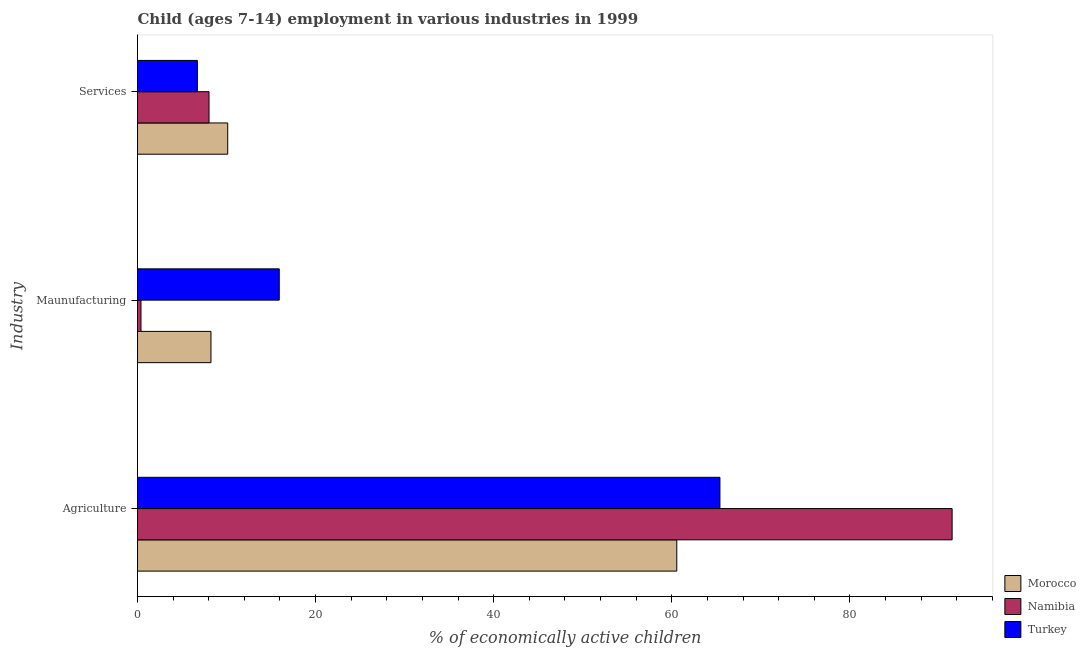How many different coloured bars are there?
Your answer should be compact. 3. How many bars are there on the 1st tick from the top?
Your response must be concise. 3. How many bars are there on the 1st tick from the bottom?
Your answer should be compact. 3. What is the label of the 1st group of bars from the top?
Your answer should be very brief. Services. What is the percentage of economically active children in manufacturing in Morocco?
Offer a very short reply. 8.25. Across all countries, what is the maximum percentage of economically active children in services?
Give a very brief answer. 10.13. Across all countries, what is the minimum percentage of economically active children in agriculture?
Provide a succinct answer. 60.56. In which country was the percentage of economically active children in manufacturing maximum?
Ensure brevity in your answer.  Turkey. What is the total percentage of economically active children in agriculture in the graph?
Ensure brevity in your answer.  217.45. What is the difference between the percentage of economically active children in services in Namibia and that in Turkey?
Your response must be concise. 1.31. What is the difference between the percentage of economically active children in services in Turkey and the percentage of economically active children in agriculture in Namibia?
Your answer should be compact. -84.76. What is the average percentage of economically active children in agriculture per country?
Your response must be concise. 72.48. What is the difference between the percentage of economically active children in manufacturing and percentage of economically active children in services in Namibia?
Your answer should be compact. -7.64. In how many countries, is the percentage of economically active children in services greater than 88 %?
Offer a terse response. 0. What is the ratio of the percentage of economically active children in agriculture in Turkey to that in Morocco?
Keep it short and to the point. 1.08. Is the percentage of economically active children in services in Turkey less than that in Namibia?
Provide a succinct answer. Yes. What is the difference between the highest and the second highest percentage of economically active children in agriculture?
Provide a short and direct response. 26.07. What is the difference between the highest and the lowest percentage of economically active children in agriculture?
Offer a very short reply. 30.92. In how many countries, is the percentage of economically active children in manufacturing greater than the average percentage of economically active children in manufacturing taken over all countries?
Ensure brevity in your answer.  2. What does the 3rd bar from the top in Agriculture represents?
Provide a short and direct response. Morocco. What does the 2nd bar from the bottom in Services represents?
Your answer should be very brief. Namibia. How many bars are there?
Your answer should be very brief. 9. Are the values on the major ticks of X-axis written in scientific E-notation?
Your response must be concise. No. Does the graph contain any zero values?
Your answer should be very brief. No. Does the graph contain grids?
Your response must be concise. No. How many legend labels are there?
Keep it short and to the point. 3. What is the title of the graph?
Your answer should be very brief. Child (ages 7-14) employment in various industries in 1999. What is the label or title of the X-axis?
Ensure brevity in your answer.  % of economically active children. What is the label or title of the Y-axis?
Offer a terse response. Industry. What is the % of economically active children of Morocco in Agriculture?
Give a very brief answer. 60.56. What is the % of economically active children of Namibia in Agriculture?
Offer a very short reply. 91.48. What is the % of economically active children in Turkey in Agriculture?
Give a very brief answer. 65.41. What is the % of economically active children of Morocco in Maunufacturing?
Make the answer very short. 8.25. What is the % of economically active children in Namibia in Maunufacturing?
Provide a short and direct response. 0.39. What is the % of economically active children in Turkey in Maunufacturing?
Your response must be concise. 15.92. What is the % of economically active children in Morocco in Services?
Your answer should be very brief. 10.13. What is the % of economically active children in Namibia in Services?
Your response must be concise. 8.03. What is the % of economically active children in Turkey in Services?
Make the answer very short. 6.72. Across all Industry, what is the maximum % of economically active children of Morocco?
Make the answer very short. 60.56. Across all Industry, what is the maximum % of economically active children of Namibia?
Your answer should be very brief. 91.48. Across all Industry, what is the maximum % of economically active children in Turkey?
Your answer should be compact. 65.41. Across all Industry, what is the minimum % of economically active children in Morocco?
Provide a succinct answer. 8.25. Across all Industry, what is the minimum % of economically active children in Namibia?
Provide a short and direct response. 0.39. Across all Industry, what is the minimum % of economically active children in Turkey?
Your answer should be compact. 6.72. What is the total % of economically active children of Morocco in the graph?
Offer a terse response. 78.94. What is the total % of economically active children in Namibia in the graph?
Provide a succinct answer. 99.9. What is the total % of economically active children in Turkey in the graph?
Ensure brevity in your answer.  88.05. What is the difference between the % of economically active children of Morocco in Agriculture and that in Maunufacturing?
Your answer should be compact. 52.31. What is the difference between the % of economically active children of Namibia in Agriculture and that in Maunufacturing?
Ensure brevity in your answer.  91.09. What is the difference between the % of economically active children of Turkey in Agriculture and that in Maunufacturing?
Your answer should be very brief. 49.49. What is the difference between the % of economically active children in Morocco in Agriculture and that in Services?
Your response must be concise. 50.43. What is the difference between the % of economically active children in Namibia in Agriculture and that in Services?
Provide a succinct answer. 83.45. What is the difference between the % of economically active children of Turkey in Agriculture and that in Services?
Make the answer very short. 58.68. What is the difference between the % of economically active children of Morocco in Maunufacturing and that in Services?
Provide a succinct answer. -1.88. What is the difference between the % of economically active children of Namibia in Maunufacturing and that in Services?
Your answer should be compact. -7.64. What is the difference between the % of economically active children in Turkey in Maunufacturing and that in Services?
Offer a very short reply. 9.2. What is the difference between the % of economically active children of Morocco in Agriculture and the % of economically active children of Namibia in Maunufacturing?
Keep it short and to the point. 60.17. What is the difference between the % of economically active children of Morocco in Agriculture and the % of economically active children of Turkey in Maunufacturing?
Offer a terse response. 44.64. What is the difference between the % of economically active children of Namibia in Agriculture and the % of economically active children of Turkey in Maunufacturing?
Offer a very short reply. 75.56. What is the difference between the % of economically active children in Morocco in Agriculture and the % of economically active children in Namibia in Services?
Your answer should be very brief. 52.53. What is the difference between the % of economically active children of Morocco in Agriculture and the % of economically active children of Turkey in Services?
Offer a very short reply. 53.84. What is the difference between the % of economically active children of Namibia in Agriculture and the % of economically active children of Turkey in Services?
Offer a very short reply. 84.76. What is the difference between the % of economically active children of Morocco in Maunufacturing and the % of economically active children of Namibia in Services?
Provide a short and direct response. 0.22. What is the difference between the % of economically active children in Morocco in Maunufacturing and the % of economically active children in Turkey in Services?
Make the answer very short. 1.53. What is the difference between the % of economically active children in Namibia in Maunufacturing and the % of economically active children in Turkey in Services?
Offer a very short reply. -6.33. What is the average % of economically active children of Morocco per Industry?
Provide a short and direct response. 26.31. What is the average % of economically active children of Namibia per Industry?
Keep it short and to the point. 33.3. What is the average % of economically active children in Turkey per Industry?
Keep it short and to the point. 29.35. What is the difference between the % of economically active children in Morocco and % of economically active children in Namibia in Agriculture?
Ensure brevity in your answer.  -30.92. What is the difference between the % of economically active children in Morocco and % of economically active children in Turkey in Agriculture?
Give a very brief answer. -4.85. What is the difference between the % of economically active children in Namibia and % of economically active children in Turkey in Agriculture?
Your answer should be compact. 26.07. What is the difference between the % of economically active children in Morocco and % of economically active children in Namibia in Maunufacturing?
Keep it short and to the point. 7.86. What is the difference between the % of economically active children in Morocco and % of economically active children in Turkey in Maunufacturing?
Your answer should be very brief. -7.67. What is the difference between the % of economically active children of Namibia and % of economically active children of Turkey in Maunufacturing?
Provide a short and direct response. -15.53. What is the difference between the % of economically active children of Morocco and % of economically active children of Turkey in Services?
Your answer should be very brief. 3.41. What is the difference between the % of economically active children in Namibia and % of economically active children in Turkey in Services?
Offer a terse response. 1.31. What is the ratio of the % of economically active children of Morocco in Agriculture to that in Maunufacturing?
Offer a terse response. 7.34. What is the ratio of the % of economically active children of Namibia in Agriculture to that in Maunufacturing?
Provide a short and direct response. 234.56. What is the ratio of the % of economically active children of Turkey in Agriculture to that in Maunufacturing?
Give a very brief answer. 4.11. What is the ratio of the % of economically active children of Morocco in Agriculture to that in Services?
Make the answer very short. 5.98. What is the ratio of the % of economically active children in Namibia in Agriculture to that in Services?
Make the answer very short. 11.39. What is the ratio of the % of economically active children of Turkey in Agriculture to that in Services?
Offer a very short reply. 9.73. What is the ratio of the % of economically active children of Morocco in Maunufacturing to that in Services?
Your answer should be compact. 0.81. What is the ratio of the % of economically active children of Namibia in Maunufacturing to that in Services?
Keep it short and to the point. 0.05. What is the ratio of the % of economically active children of Turkey in Maunufacturing to that in Services?
Offer a very short reply. 2.37. What is the difference between the highest and the second highest % of economically active children of Morocco?
Make the answer very short. 50.43. What is the difference between the highest and the second highest % of economically active children of Namibia?
Your answer should be very brief. 83.45. What is the difference between the highest and the second highest % of economically active children in Turkey?
Keep it short and to the point. 49.49. What is the difference between the highest and the lowest % of economically active children of Morocco?
Your answer should be very brief. 52.31. What is the difference between the highest and the lowest % of economically active children in Namibia?
Your answer should be compact. 91.09. What is the difference between the highest and the lowest % of economically active children in Turkey?
Your answer should be very brief. 58.68. 